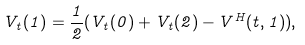Convert formula to latex. <formula><loc_0><loc_0><loc_500><loc_500>V _ { t } ( 1 ) = \frac { 1 } { 2 } ( V _ { t } ( 0 ) + V _ { t } ( 2 ) - V ^ { H } ( t , 1 ) ) ,</formula> 